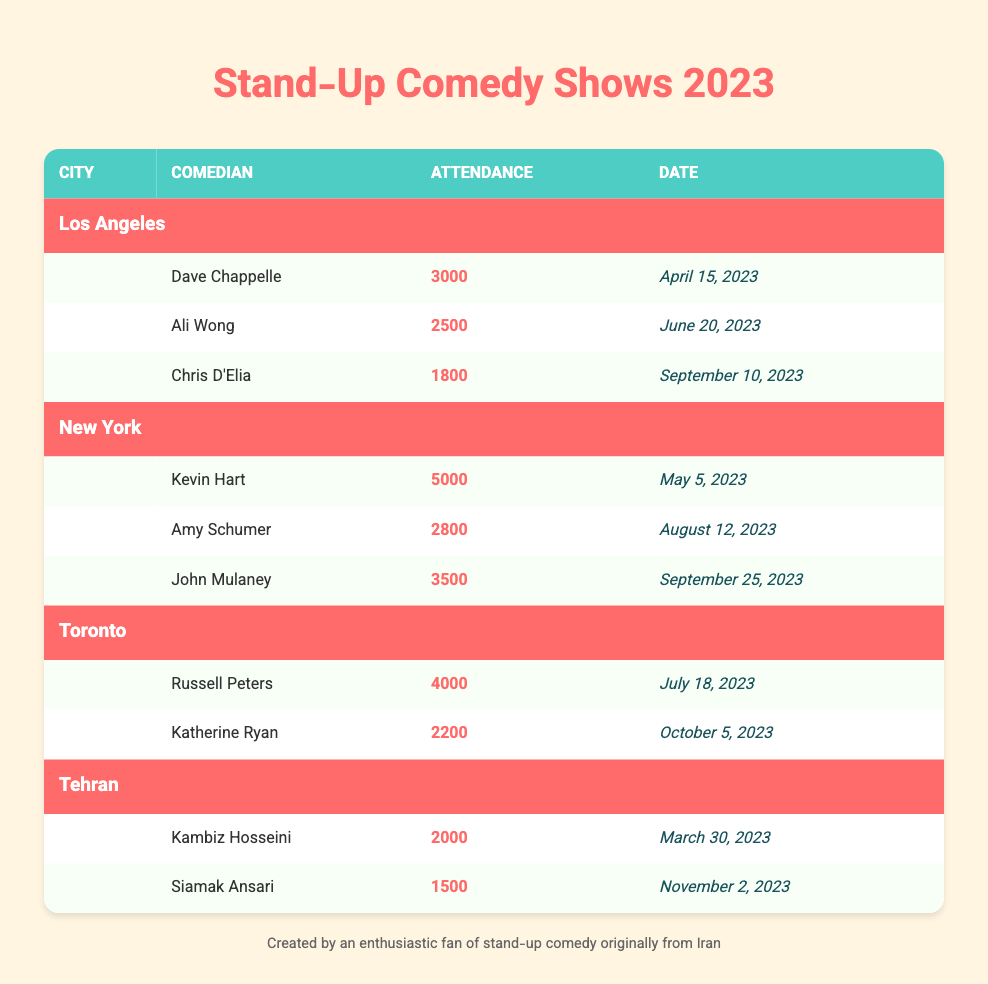What's the total attendance for stand-up comedy shows in New York? To find the total attendance for New York, we need to add the attendance figures for each comedian. The attendance numbers are: 5000 (Kevin Hart) + 2800 (Amy Schumer) + 3500 (John Mulaney) = 11300.
Answer: 11300 Who had the highest attendance in Los Angeles? In the Los Angeles section, the attendance numbers are: 3000 (Dave Chappelle), 2500 (Ali Wong), and 1800 (Chris D'Elia). The highest attendance is 3000 from Dave Chappelle.
Answer: Dave Chappelle Is the attendance for Kambiz Hosseini greater than Siamak Ansari's attendance? Kambiz Hosseini had an attendance of 2000, while Siamak Ansari had 1500. Since 2000 is greater than 1500, the answer is yes.
Answer: Yes What is the average attendance for comedians in Toronto? The attendance figures for Toronto are: 4000 (Russell Peters) and 2200 (Katherine Ryan). To find the average, we sum them: 4000 + 2200 = 6200, and then divide by the count of comedians, which is 2. So, 6200 / 2 = 3100.
Answer: 3100 Which city has the comedian with the lowest attendance? Scanning the cities, we see the lowest attendance: Chris D'Elia in Los Angeles has 1800, while Siamak Ansari in Tehran has 1500. The lowest attendance is in Tehran with Siamak Ansari.
Answer: Tehran How many people attended the shows in total across all cities? To find the total attendance for all cities, we add the attendance for each comedian across all locations. The total is: 3000 (LA) + 2500 (LA) + 1800 (LA) + 5000 (NY) + 2800 (NY) + 3500 (NY) + 4000 (Toronto) + 2200 (Toronto) + 2000 (Tehran) + 1500 (Tehran) =  22600.
Answer: 22600 Did any comedian in Toronto have an attendance of more than 3000? The comedians in Toronto had attendance of 4000 (Russell Peters) and 2200 (Katherine Ryan). Since 4000 is greater than 3000, the answer is yes.
Answer: Yes What comedian had the second highest attendance in New York? In New York, the attendance is as follows: 5000 (Kevin Hart), 3500 (John Mulaney), and 2800 (Amy Schumer). The second highest is 3500 by John Mulaney.
Answer: John Mulaney 